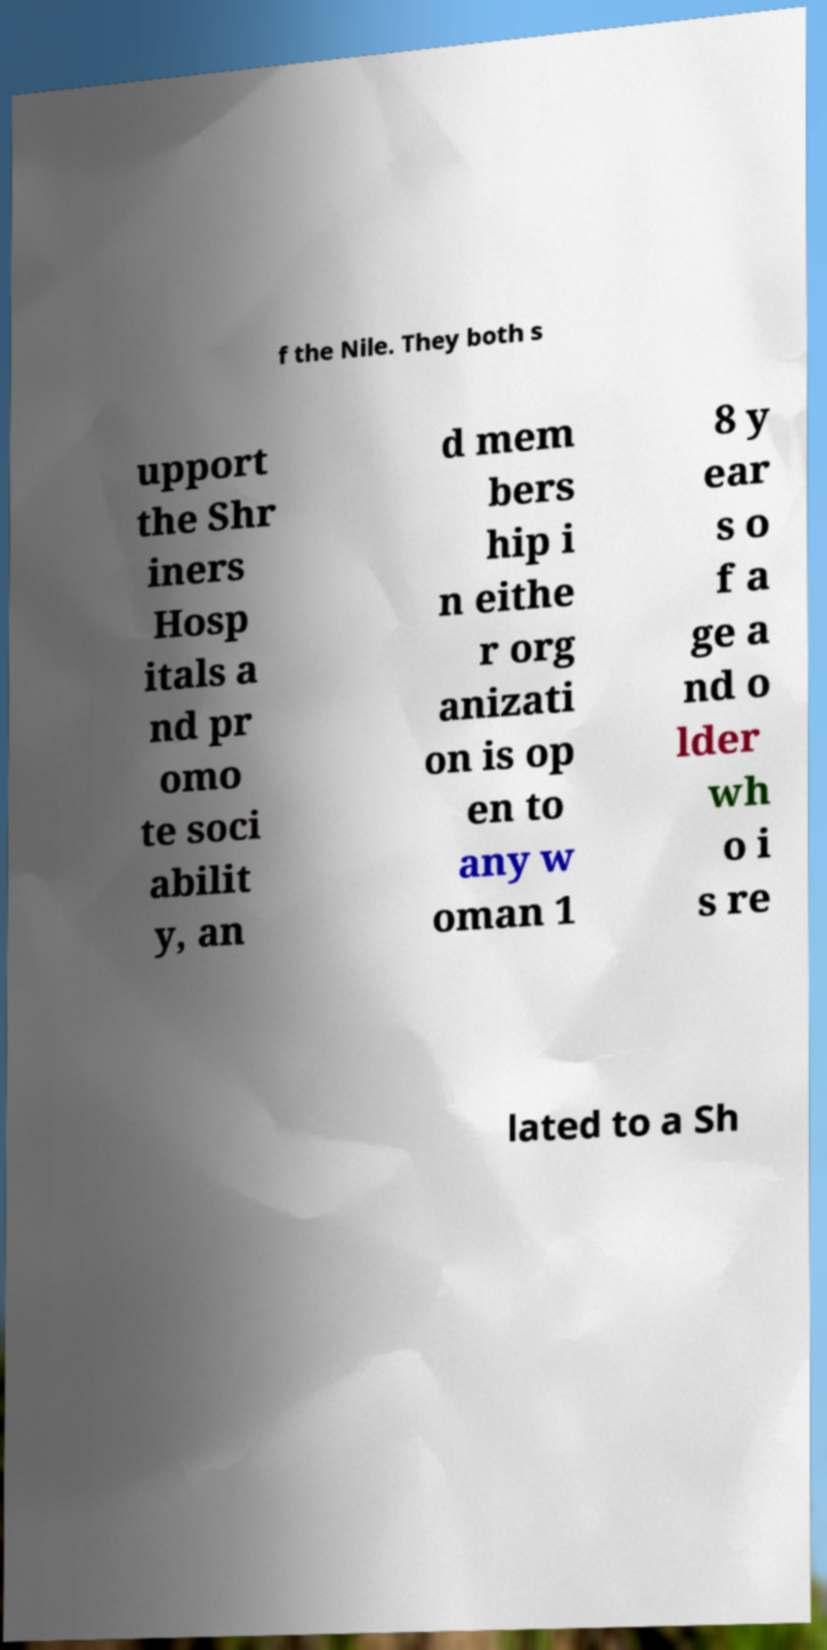Please read and relay the text visible in this image. What does it say? f the Nile. They both s upport the Shr iners Hosp itals a nd pr omo te soci abilit y, an d mem bers hip i n eithe r org anizati on is op en to any w oman 1 8 y ear s o f a ge a nd o lder wh o i s re lated to a Sh 